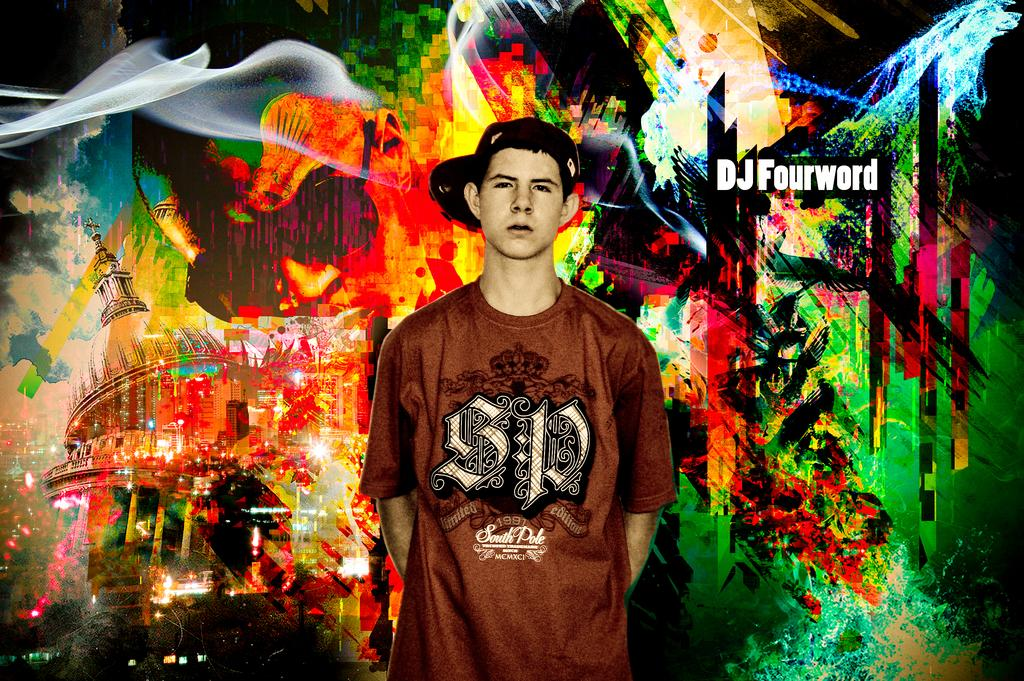What is the main subject of the image? There is a man standing in the image. Can you describe the man's attire? The man is wearing a cap. What can be seen on the wall in the image? There is a painting on the wall in the image. Is there any additional detail visible in the image? Yes, there is a watermark visible in the image. Where is the sink located in the image? There is no sink present in the image. Can you describe the spot on the man's shirt in the image? There is no spot visible on the man's shirt in the image. 